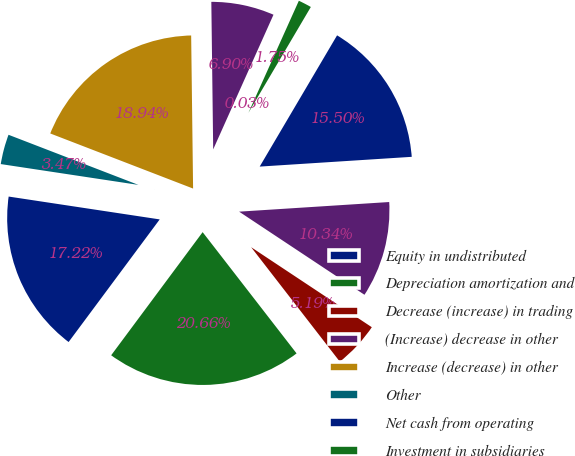Convert chart. <chart><loc_0><loc_0><loc_500><loc_500><pie_chart><fcel>Equity in undistributed<fcel>Depreciation amortization and<fcel>Decrease (increase) in trading<fcel>(Increase) decrease in other<fcel>Increase (decrease) in other<fcel>Other<fcel>Net cash from operating<fcel>Investment in subsidiaries<fcel>Net sales of premises and<fcel>Proceeds from sales and<nl><fcel>15.5%<fcel>1.75%<fcel>0.03%<fcel>6.9%<fcel>18.94%<fcel>3.47%<fcel>17.22%<fcel>20.66%<fcel>5.19%<fcel>10.34%<nl></chart> 